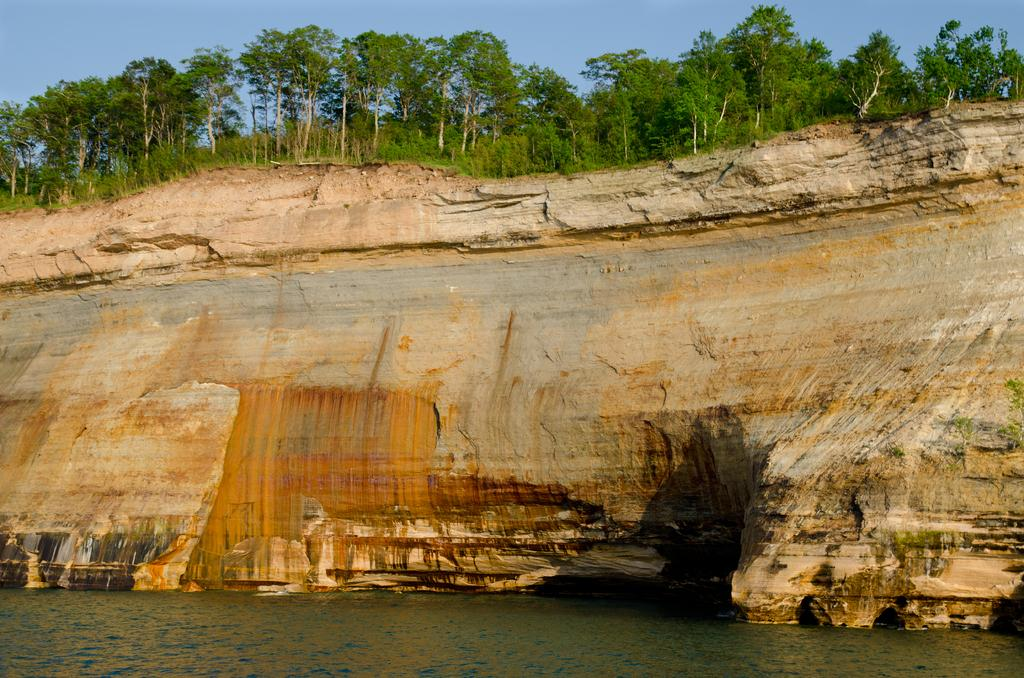What geographical feature is present in the image? There is a hill in the image. What can be found on the hill? There are trees on the hill. What else is visible in the image besides the hill and trees? There is water visible in the image. What is the background of the image? There is a sky in the background of the image. Can you see a woman pulling up her trousers in the image? There is no woman or trousers present in the image. 